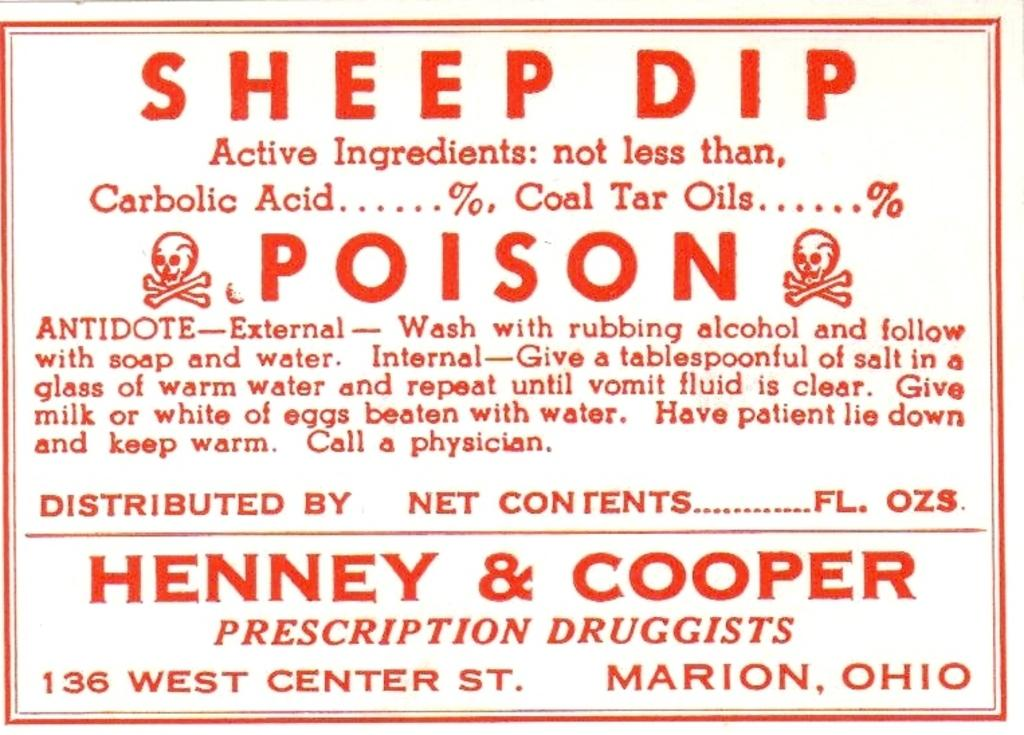<image>
Render a clear and concise summary of the photo. A sticker that  contains the word poison, it gives directions upon how to use along with the pharmacists names and address. 